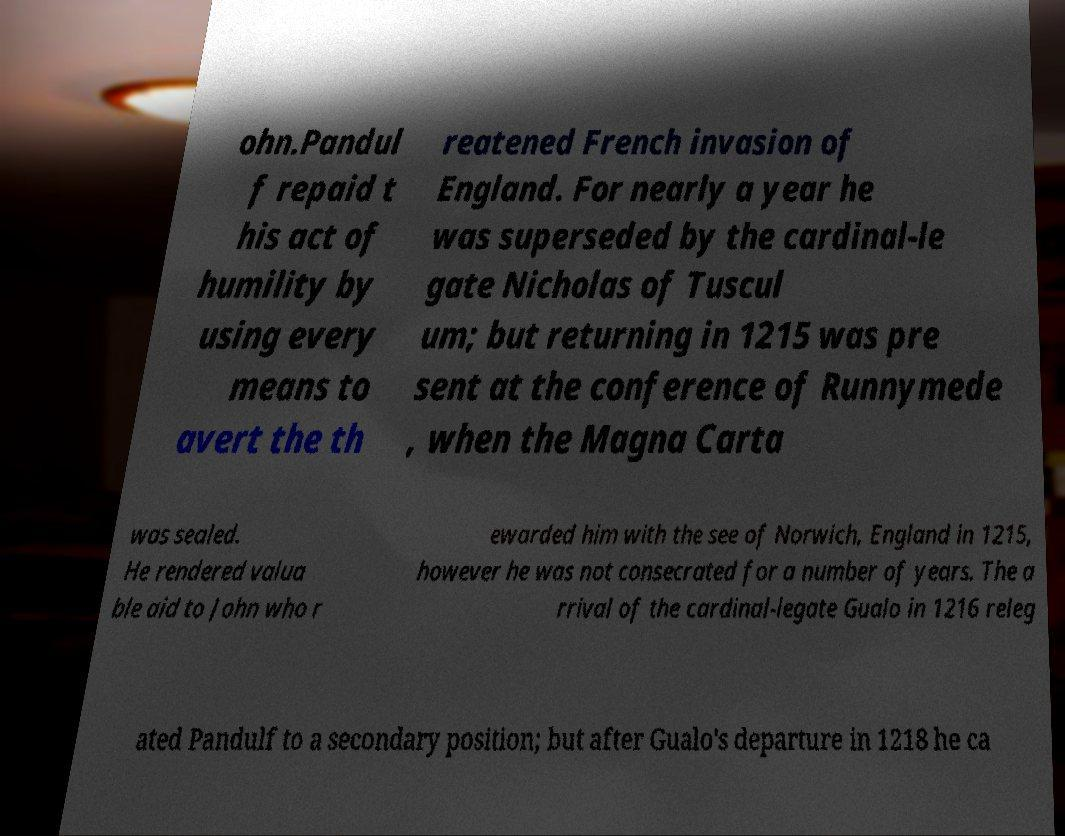Please identify and transcribe the text found in this image. ohn.Pandul f repaid t his act of humility by using every means to avert the th reatened French invasion of England. For nearly a year he was superseded by the cardinal-le gate Nicholas of Tuscul um; but returning in 1215 was pre sent at the conference of Runnymede , when the Magna Carta was sealed. He rendered valua ble aid to John who r ewarded him with the see of Norwich, England in 1215, however he was not consecrated for a number of years. The a rrival of the cardinal-legate Gualo in 1216 releg ated Pandulf to a secondary position; but after Gualo's departure in 1218 he ca 